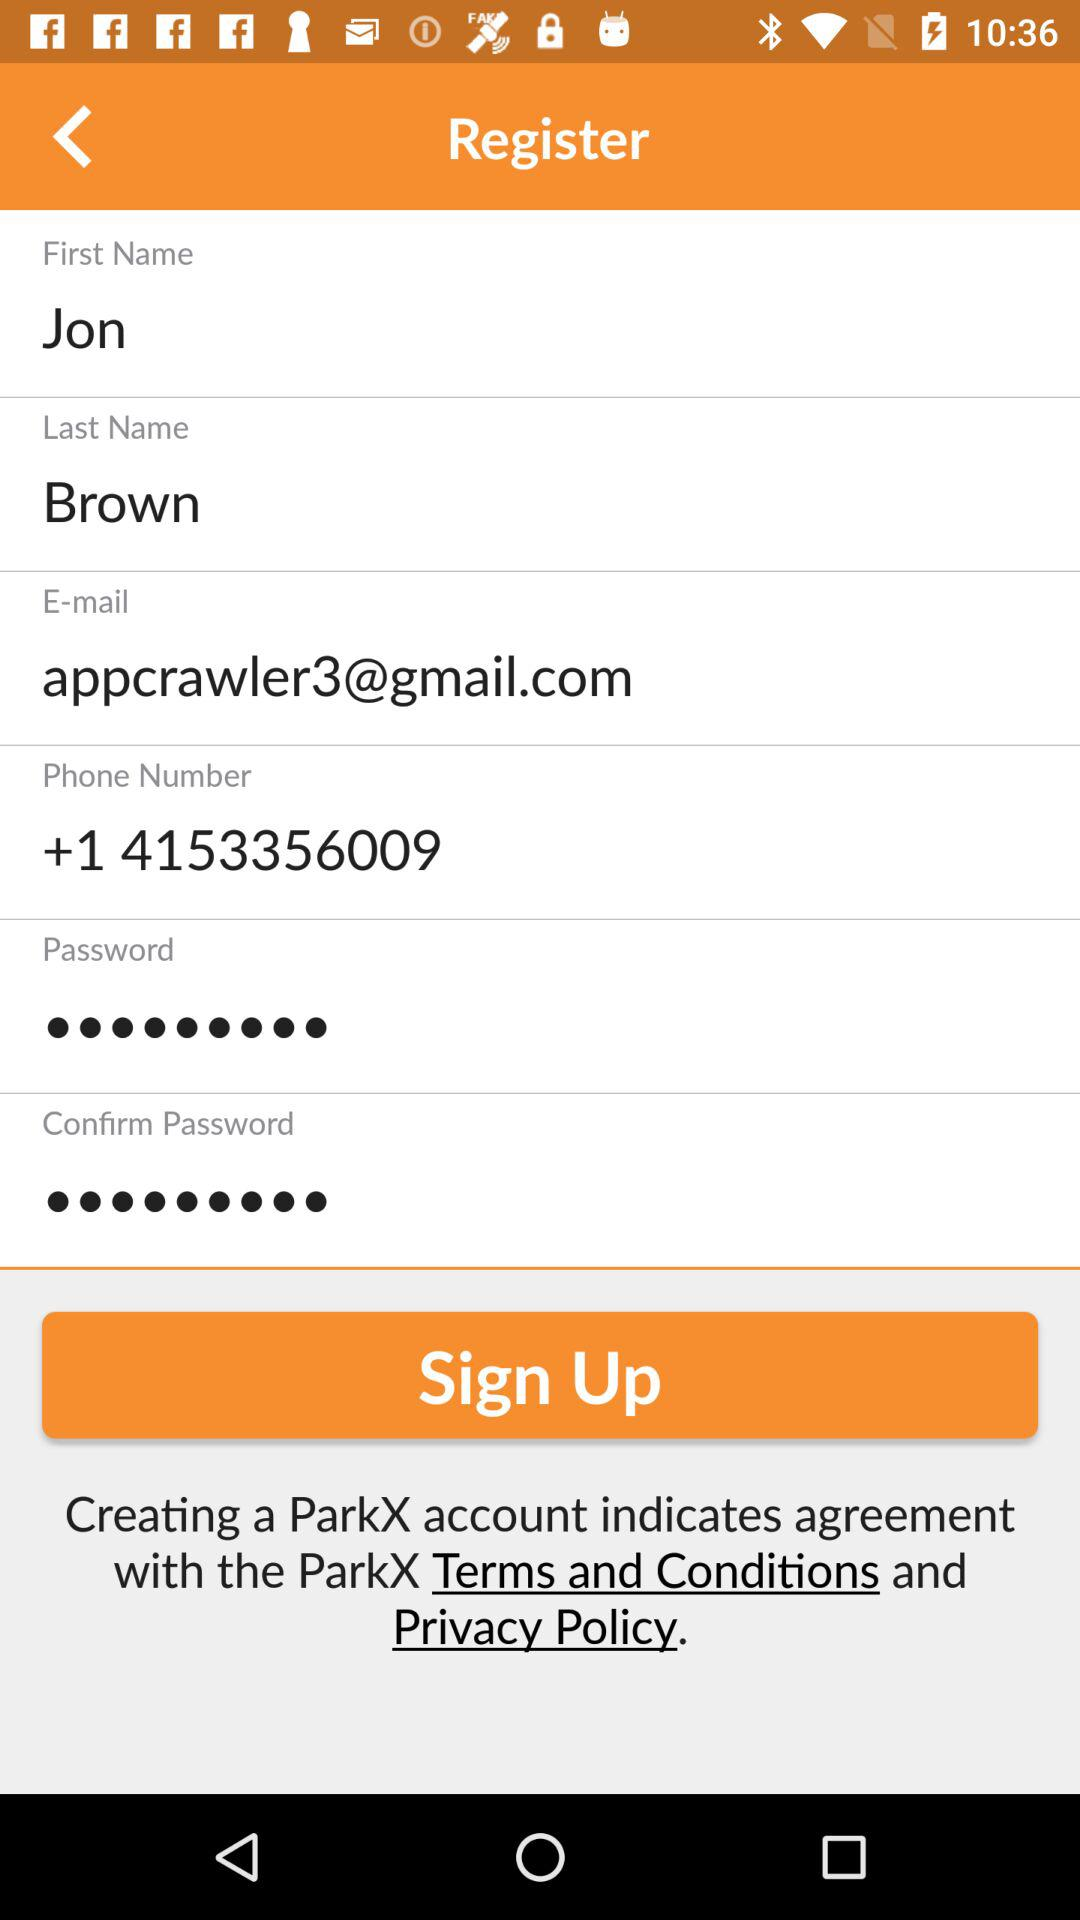What is the email address? The email address is "appcrawler3@gmail.com". 